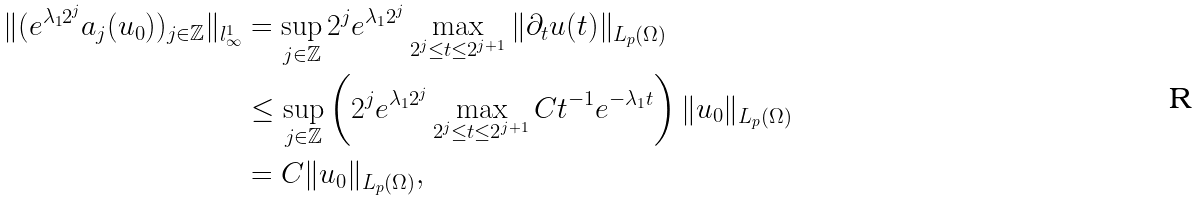<formula> <loc_0><loc_0><loc_500><loc_500>\| ( e ^ { \lambda _ { 1 } 2 ^ { j } } a _ { j } ( u _ { 0 } ) ) _ { j \in \mathbb { Z } } \| _ { l ^ { 1 } _ { \infty } } & = \sup _ { j \in \mathbb { Z } } 2 ^ { j } e ^ { \lambda _ { 1 } 2 ^ { j } } \max _ { 2 ^ { j } \leq t \leq 2 ^ { j + 1 } } \| \partial _ { t } u ( t ) \| _ { L _ { p } ( \Omega ) } \\ & \leq \sup _ { j \in \mathbb { Z } } \left ( 2 ^ { j } e ^ { \lambda _ { 1 } 2 ^ { j } } \max _ { 2 ^ { j } \leq t \leq 2 ^ { j + 1 } } C t ^ { - 1 } e ^ { - \lambda _ { 1 } t } \right ) \| u _ { 0 } \| _ { L _ { p } ( \Omega ) } \\ & = C \| u _ { 0 } \| _ { L _ { p } ( \Omega ) } ,</formula> 